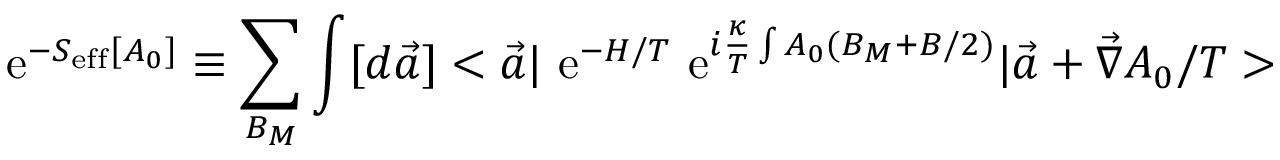Convert formula to latex. <formula><loc_0><loc_0><loc_500><loc_500>e ^ { - S _ { e f f } [ A _ { 0 } ] } \equiv \sum _ { B _ { M } } \int [ d \vec { a } ] < \vec { a } | e ^ { - H / T } e ^ { i \frac { \kappa } { T } \int A _ { 0 } ( B _ { M } + B / 2 ) } | \vec { a } + \vec { \nabla } A _ { 0 } / T ></formula> 